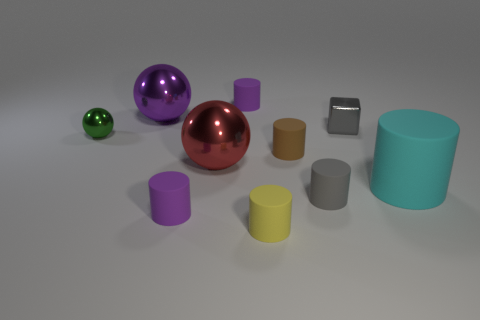Subtract all large metal balls. How many balls are left? 1 Subtract all purple balls. How many balls are left? 2 Subtract all spheres. How many objects are left? 7 Subtract all yellow blocks. How many purple cylinders are left? 2 Subtract all blue rubber spheres. Subtract all gray shiny objects. How many objects are left? 9 Add 9 cyan matte things. How many cyan matte things are left? 10 Add 4 big cyan things. How many big cyan things exist? 5 Subtract 1 brown cylinders. How many objects are left? 9 Subtract 3 balls. How many balls are left? 0 Subtract all yellow spheres. Subtract all green cylinders. How many spheres are left? 3 